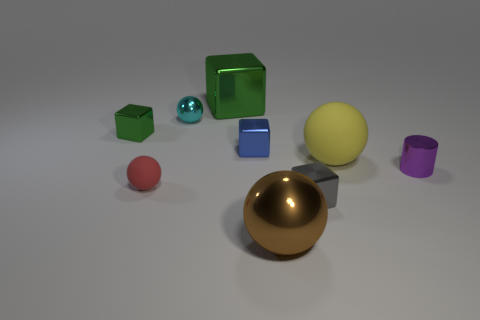Subtract all small green metallic blocks. How many blocks are left? 3 Subtract all green cubes. How many cubes are left? 2 Subtract all purple cylinders. How many green cubes are left? 2 Subtract 1 cylinders. How many cylinders are left? 0 Subtract all cylinders. How many objects are left? 8 Subtract all yellow objects. Subtract all purple objects. How many objects are left? 7 Add 2 large metal cubes. How many large metal cubes are left? 3 Add 7 tiny blue blocks. How many tiny blue blocks exist? 8 Subtract 0 yellow cylinders. How many objects are left? 9 Subtract all gray spheres. Subtract all brown cubes. How many spheres are left? 4 